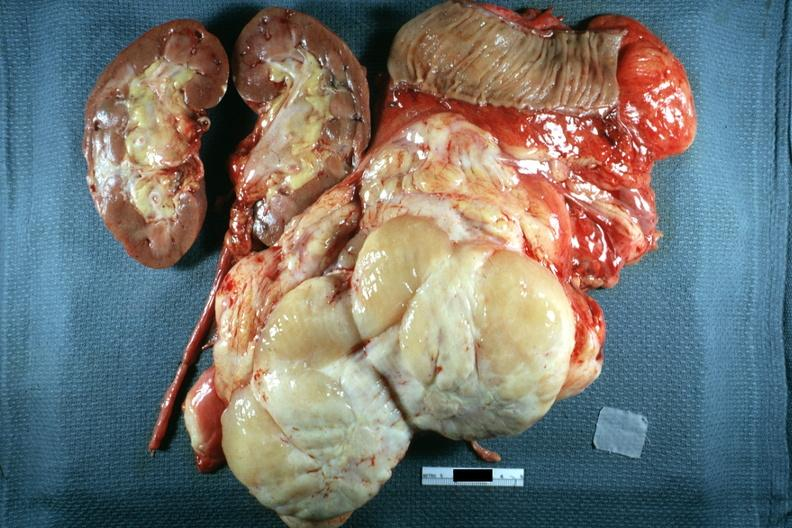what is present?
Answer the question using a single word or phrase. Abdomen 